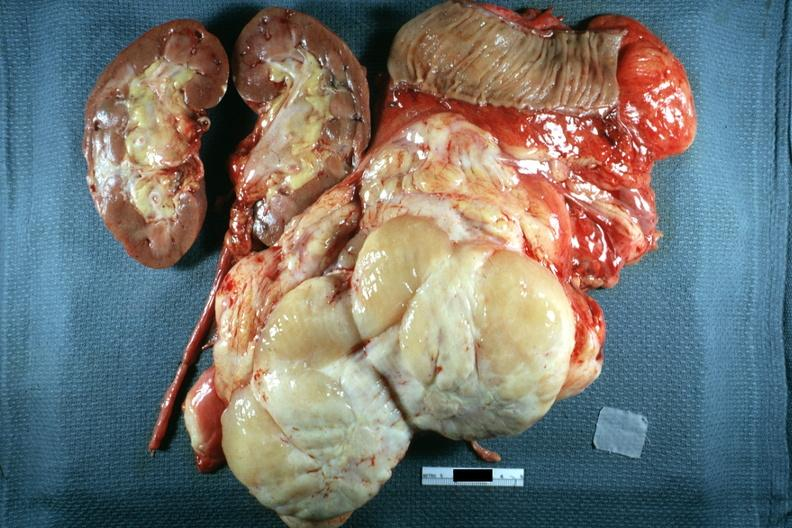what is present?
Answer the question using a single word or phrase. Abdomen 